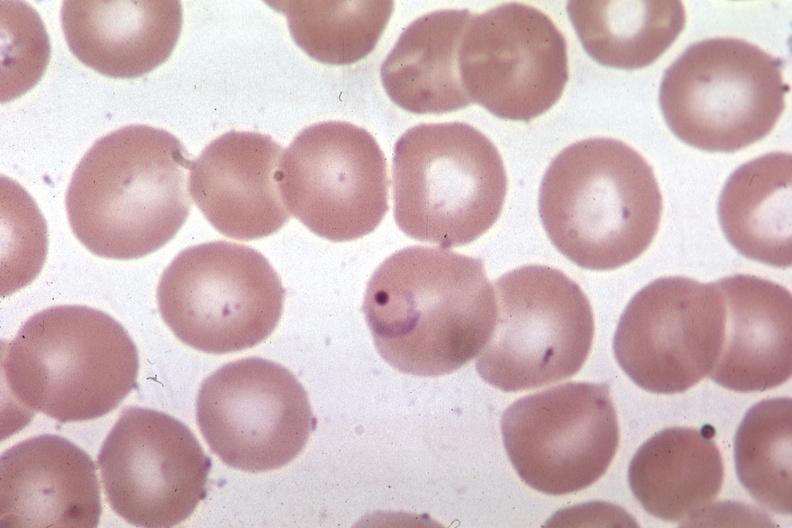what does this image show?
Answer the question using a single word or phrase. Ring form 